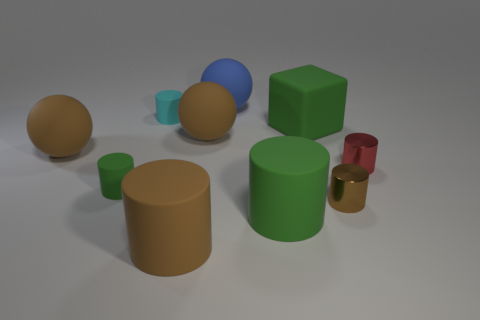Are there more green rubber cubes in front of the green matte block than big brown matte balls in front of the tiny red cylinder?
Your answer should be very brief. No. Is the material of the tiny brown cylinder the same as the large cylinder behind the large brown rubber cylinder?
Ensure brevity in your answer.  No. The big block is what color?
Make the answer very short. Green. There is a large rubber thing on the left side of the tiny cyan rubber object; what shape is it?
Your answer should be compact. Sphere. How many cyan things are cylinders or cubes?
Your answer should be very brief. 1. What color is the large block that is made of the same material as the blue thing?
Your response must be concise. Green. Does the large matte block have the same color as the large matte cylinder to the left of the blue rubber sphere?
Your answer should be very brief. No. What color is the tiny cylinder that is to the right of the blue object and left of the tiny red metallic cylinder?
Your answer should be very brief. Brown. How many objects are in front of the tiny cyan cylinder?
Provide a succinct answer. 8. How many objects are cyan matte cylinders or matte objects in front of the small green matte thing?
Offer a terse response. 3. 